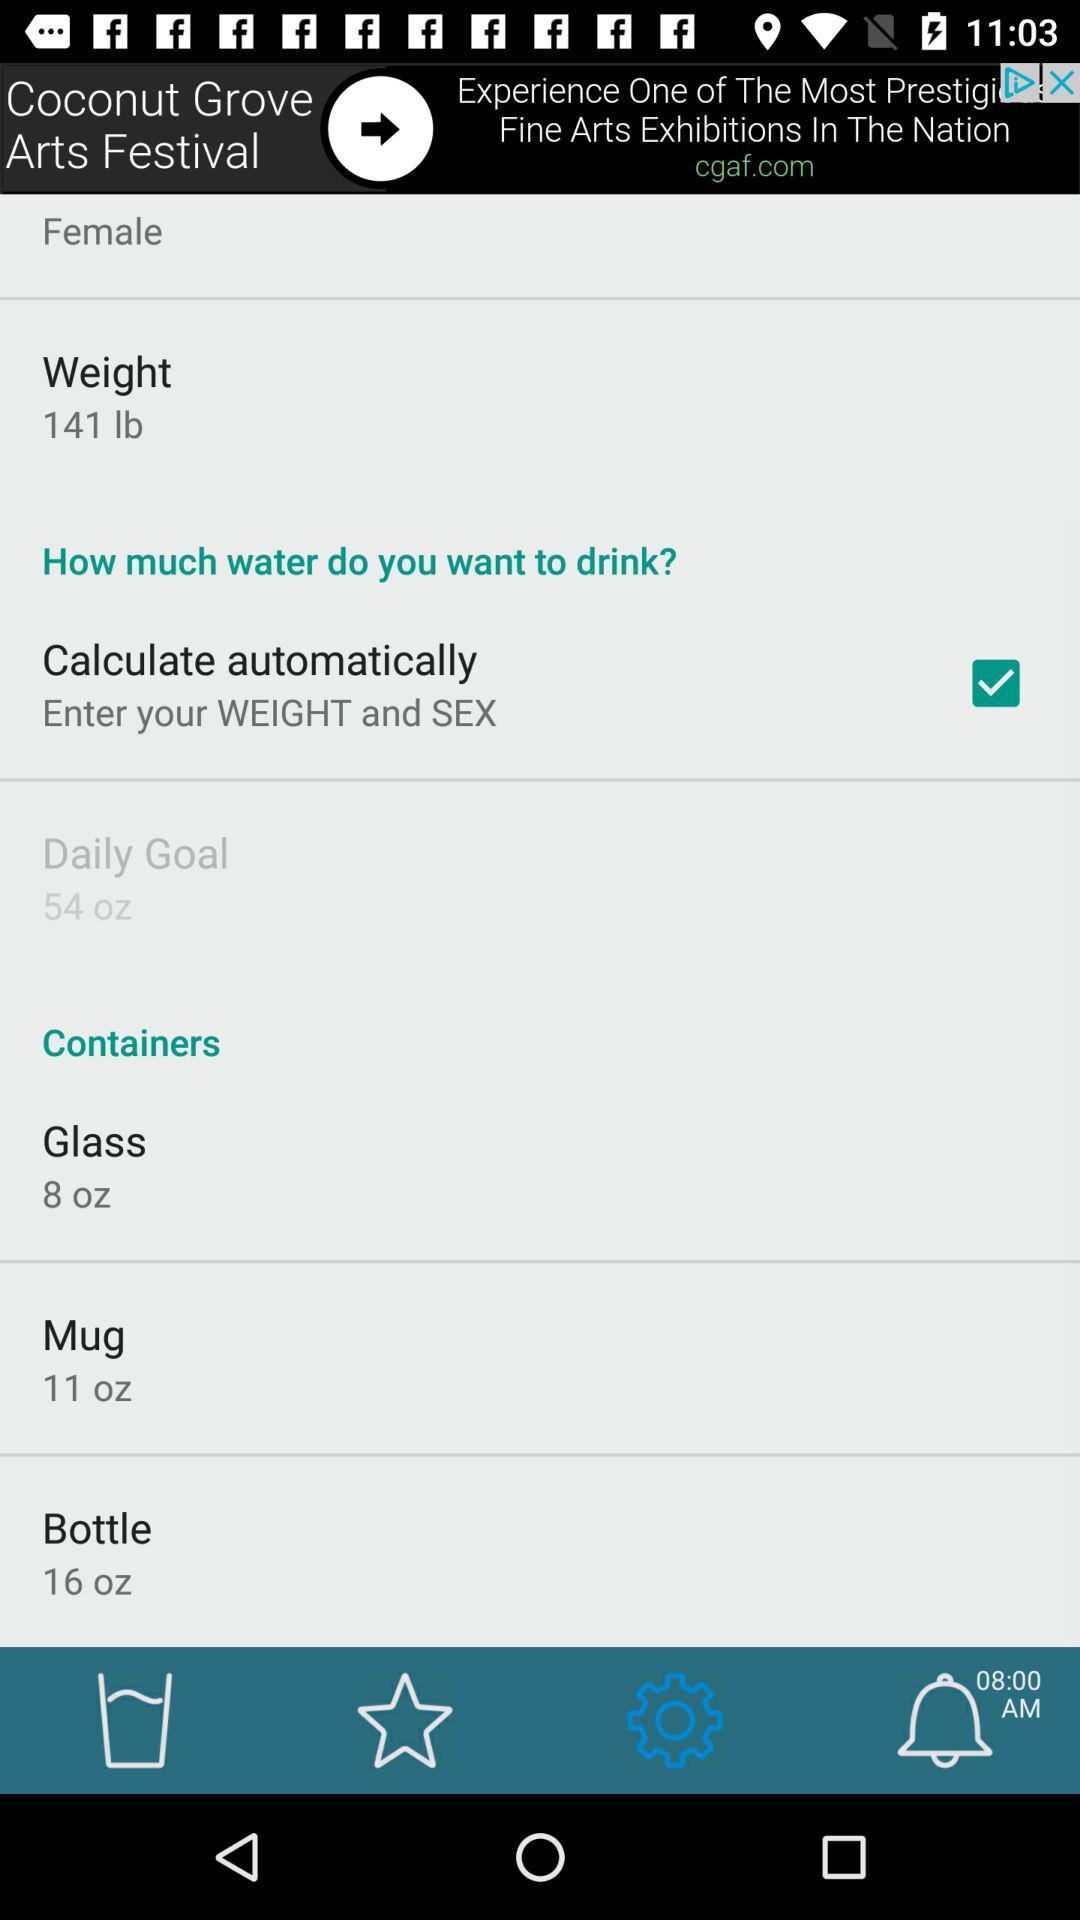What is the weight of the user?
Answer the question using a single word or phrase. 141 lb 